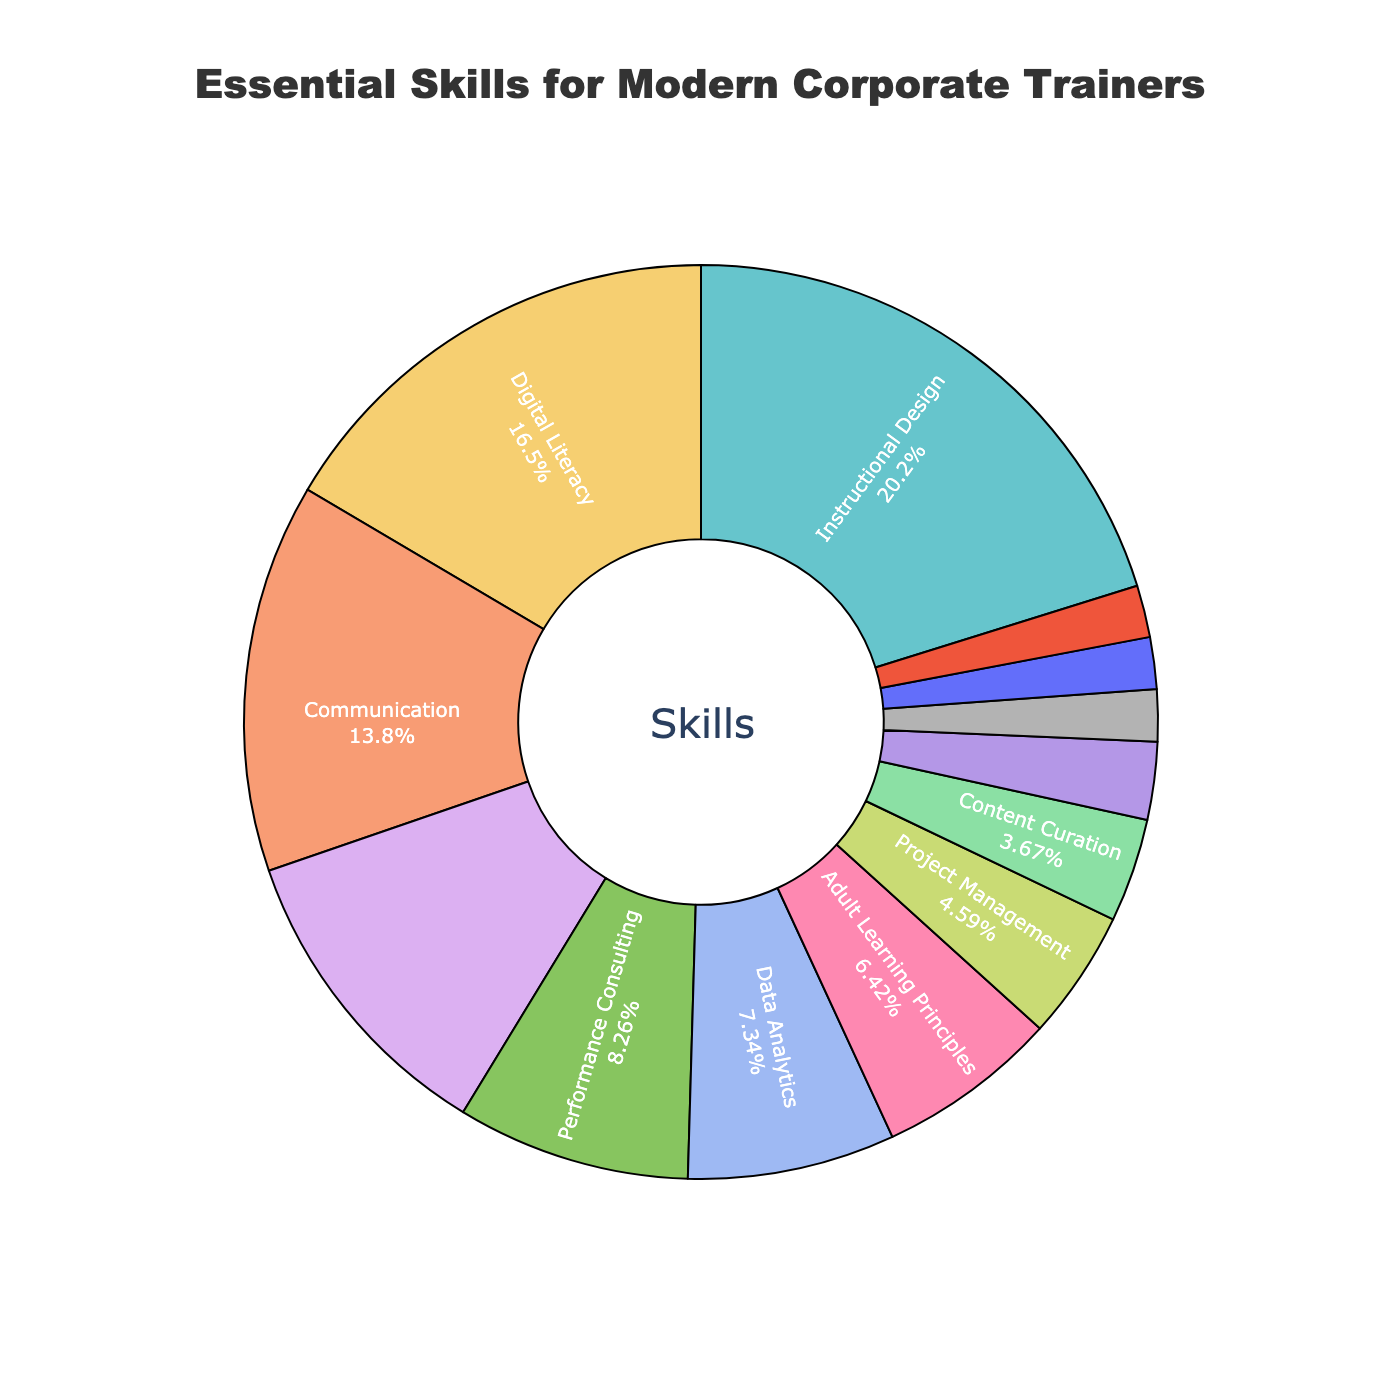What's the skill with the greatest percentage in the composition of essential skills? The visual shows that "Instructional Design" holds the largest segment of the pie chart.
Answer: Instructional Design What is the combined percentage of Digital Literacy and Communication skills? The percentages for Digital Literacy and Communication skills are 18% and 15%, respectively. Adding these together gives 33%.
Answer: 33% How much larger is the percentage of Learning Technology Proficiency compared to Project Management? Learning Technology Proficiency is at 12% and Project Management is at 5%. The difference between these is 12% - 5% = 7%.
Answer: 7% Which skill has a smaller percentage, Cultural Competence or Emotional Intelligence? Both Cultural Competence and Emotional Intelligence have the same percentage, which is 2%.
Answer: Equal How much of the pie chart is taken up by skills that have a percentage of less than 10%? The skills with percentages less than 10% are Performance Consulting (9%), Data Analytics (8%), Adult Learning Principles (7%), Project Management (5%), Content Curation (4%), Change Management (3%), Cultural Competence (2%), Emotional Intelligence (2%), and Continuous Learning (2%). Adding these percentages together gives 9 + 8 + 7 + 5 + 4 + 3 + 2 + 2 + 2 = 42%.
Answer: 42% Compare the combined percentage of Instructional Design and Digital Literacy with the combined percentage of Change Management, Cultural Competence, Emotional Intelligence, and Continuous Learning. Instructional Design (22%) + Digital Literacy (18%) = 40%. Change Management (3%) + Cultural Competence (2%) + Emotional Intelligence (2%) + Continuous Learning (2%) = 3 + 2 + 2 + 2 = 9%.
Answer: Instructional Design and Digital Literacy combined have a higher percentage What is the percentage difference between the least common essential skill and the most common essential skill? The most common skill is Instructional Design at 22%, and the least common skills are Cultural Competence, Emotional Intelligence, and Continuous Learning, each at 2%. The difference is 22% - 2% = 20%.
Answer: 20% How much of the pie chart is taken up by skills related to technology (Learning Technology Proficiency, Digital Literacy, Data Analytics)? The relevant skills are Learning Technology Proficiency (12%), Digital Literacy (18%), and Data Analytics (8%). Adding these together gives 12 + 18 + 8 = 38%.
Answer: 38% Which visual element indicates the percentage of each skill in the pie chart? The percentages of each skill are indicated by the size of each segment of the pie chart and the labels showing percentages.
Answer: Size of segments and labels showing percentages What's the total percentage of skills that fall under the top four categories? The top four categories are Instructional Design (22%), Digital Literacy (18%), Communication (15%), and Learning Technology Proficiency (12%). Adding these together gives 22 + 18 + 15 + 12 = 67%.
Answer: 67% 